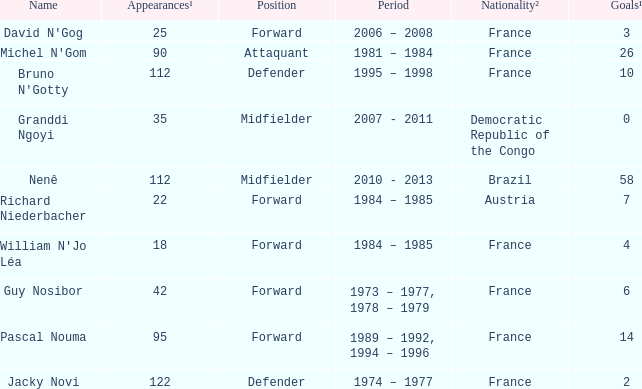List the player that scored 4 times. William N'Jo Léa. 